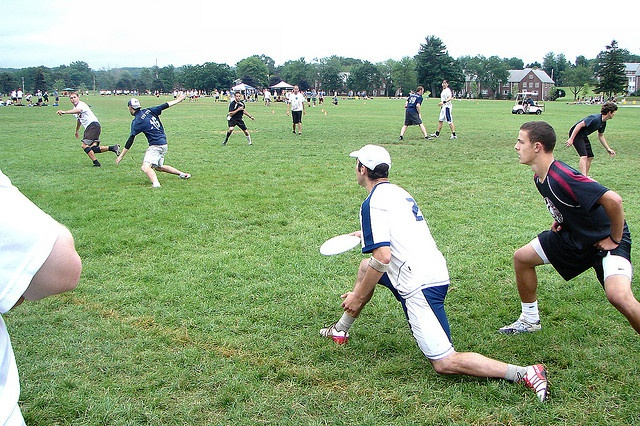Describe the objects in this image and their specific colors. I can see people in white, darkgray, black, and gray tones, people in white, black, tan, and maroon tones, people in white, darkgray, green, and gray tones, people in white, gray, darkgray, and lightgreen tones, and people in white, navy, black, and darkgray tones in this image. 